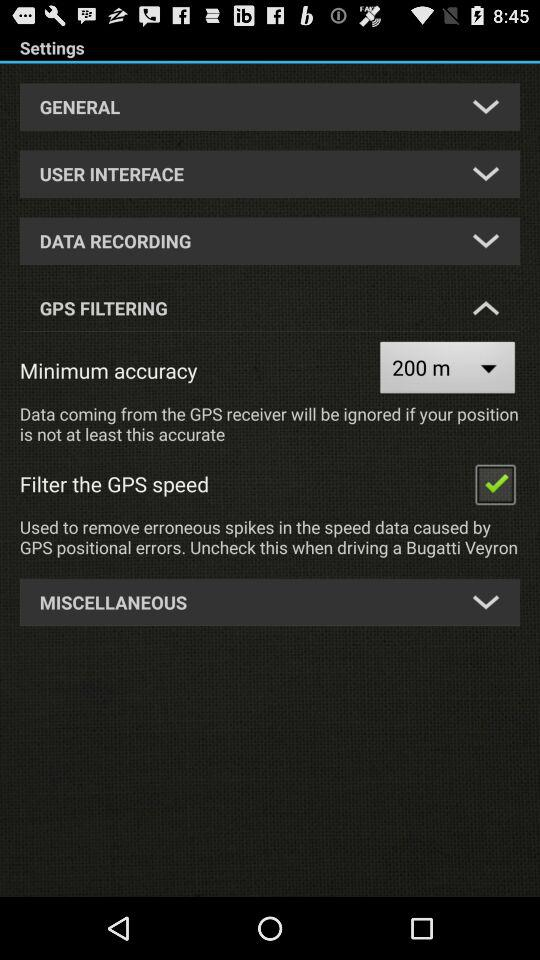What is the status of "Filter the GPS speed"? The status is "on". 